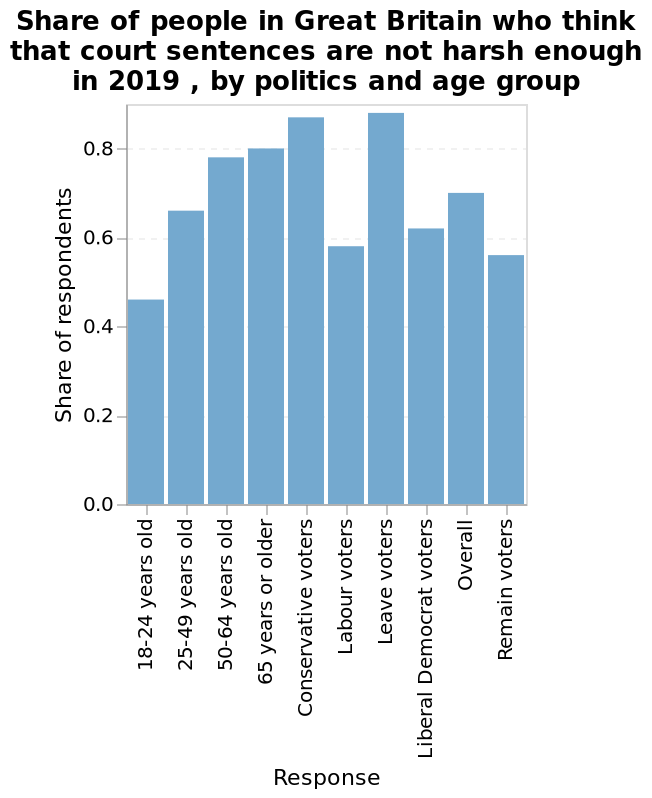<image>
Do conservative and leave voters generally think the punishment is too lenient? Yes, the majority of conservative and leave voters feel that the punishment is not harsh enough. 